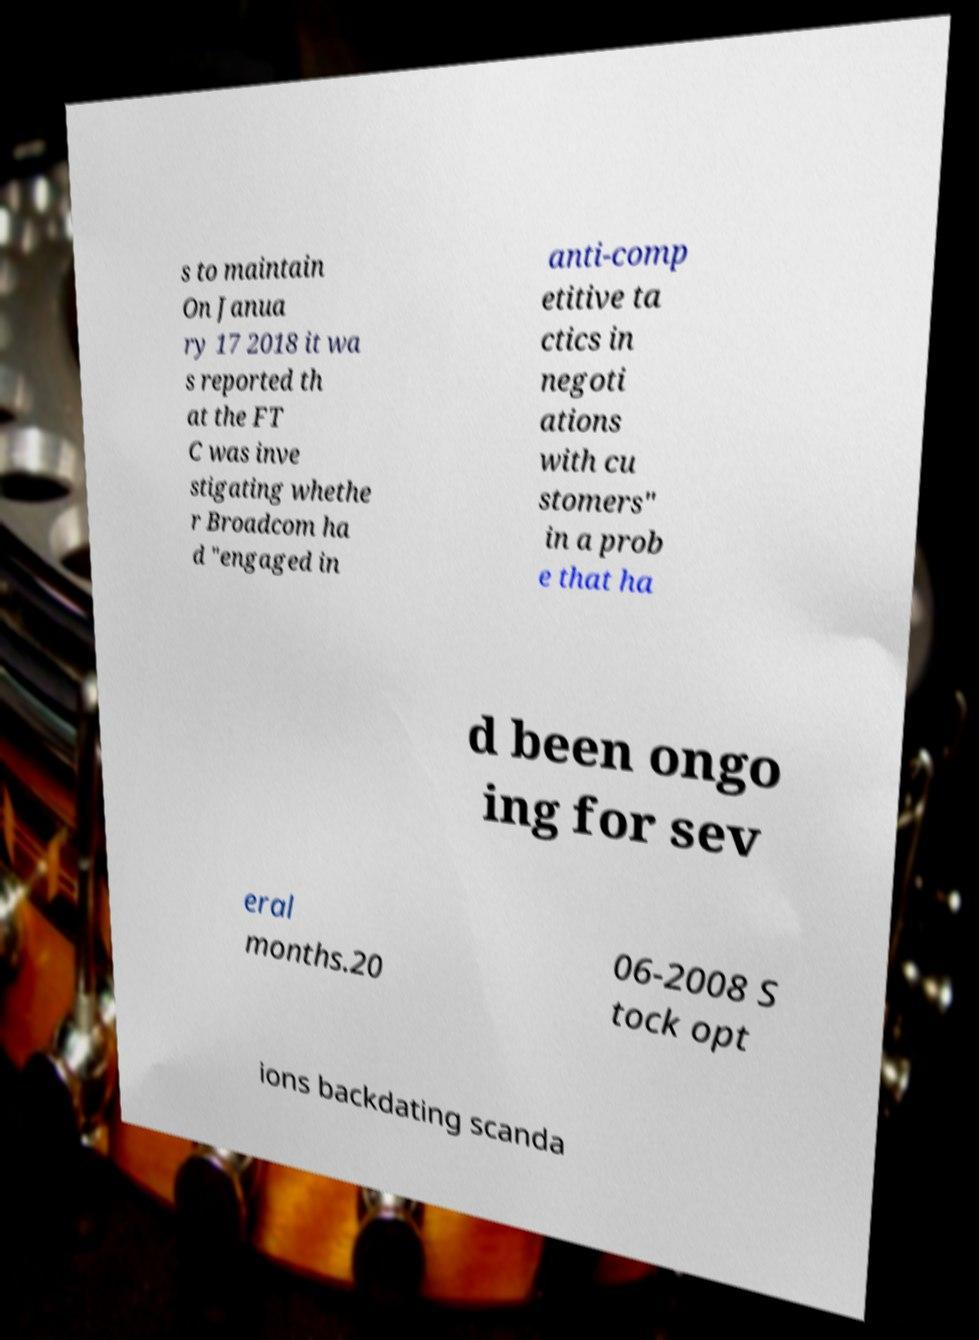Please read and relay the text visible in this image. What does it say? s to maintain On Janua ry 17 2018 it wa s reported th at the FT C was inve stigating whethe r Broadcom ha d "engaged in anti-comp etitive ta ctics in negoti ations with cu stomers" in a prob e that ha d been ongo ing for sev eral months.20 06-2008 S tock opt ions backdating scanda 